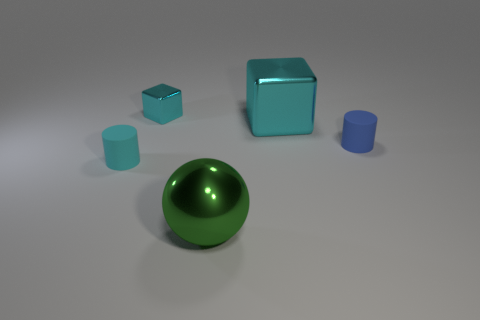What shape is the tiny rubber object behind the cyan thing in front of the matte cylinder to the right of the green shiny sphere?
Provide a short and direct response. Cylinder. How many objects are either cyan shiny things that are right of the green shiny object or tiny cylinders right of the small cyan metallic cube?
Provide a succinct answer. 2. Are there any big blocks on the left side of the big cyan thing?
Provide a short and direct response. No. How many objects are cylinders on the right side of the tiny cyan matte object or tiny cyan matte cylinders?
Offer a very short reply. 2. What number of yellow things are tiny cubes or cylinders?
Ensure brevity in your answer.  0. What number of other objects are the same color as the small metallic thing?
Keep it short and to the point. 2. Is the number of rubber things that are behind the tiny cyan rubber thing less than the number of cyan shiny blocks?
Provide a short and direct response. Yes. What is the color of the big metallic thing that is left of the cube that is right of the shiny object in front of the tiny blue matte cylinder?
Your answer should be very brief. Green. The other rubber object that is the same shape as the small cyan matte object is what size?
Your response must be concise. Small. Is the number of green spheres in front of the blue object less than the number of metal cubes behind the green thing?
Your response must be concise. Yes. 